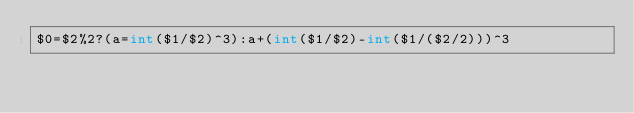<code> <loc_0><loc_0><loc_500><loc_500><_Awk_>$0=$2%2?(a=int($1/$2)^3):a+(int($1/$2)-int($1/($2/2)))^3</code> 